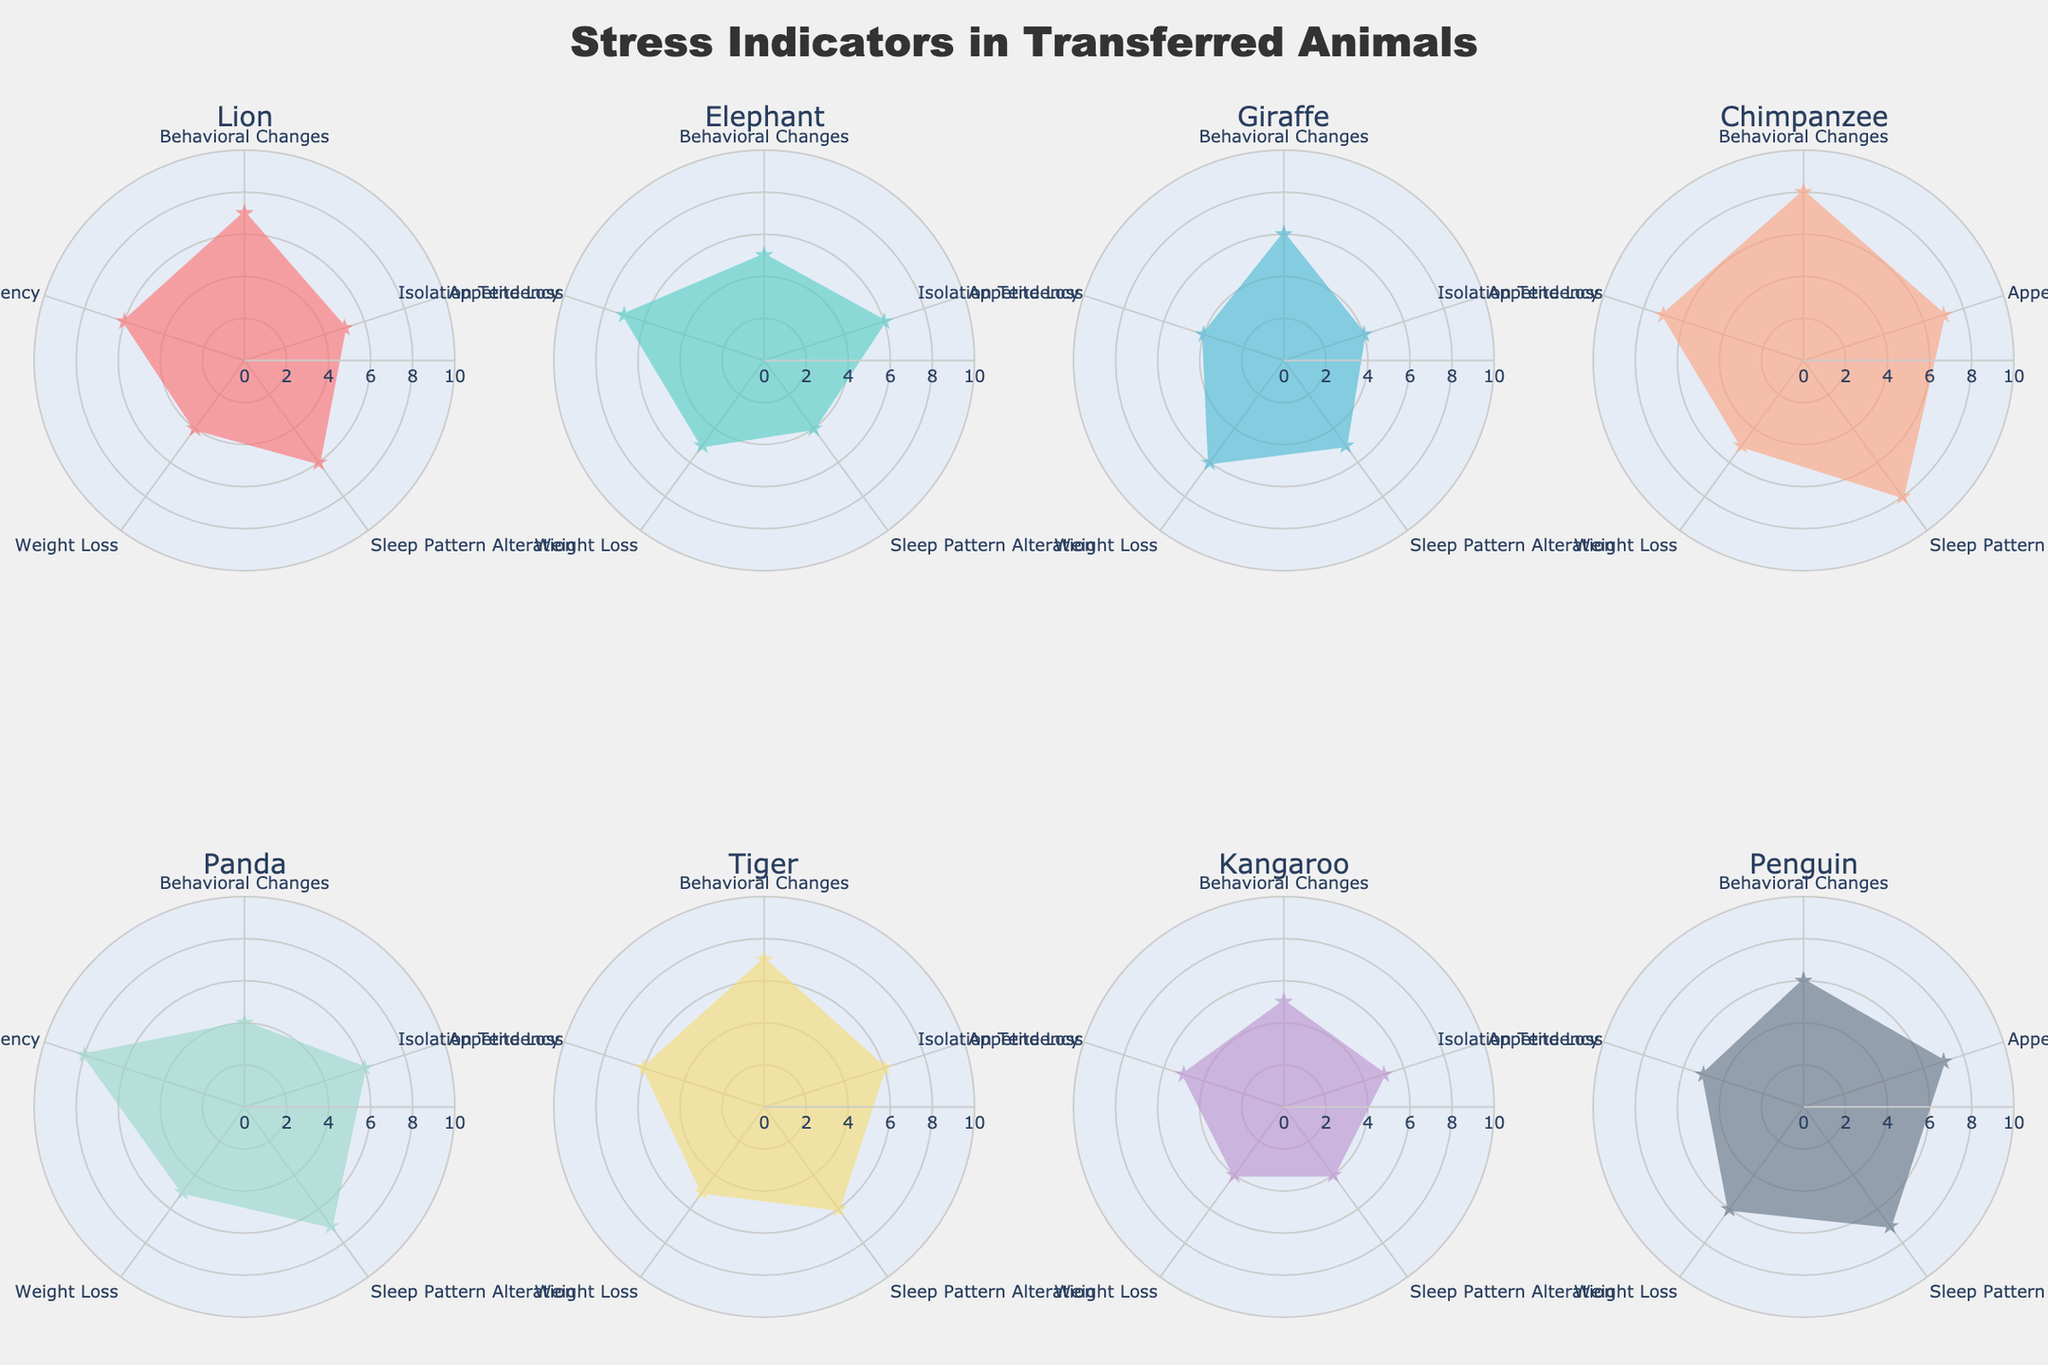What's the title of the figure? The title is usually displayed prominently at the top of the chart. It summarizes the main topic of the figure. In this case, the title says "Stress Indicators in Transferred Animals".
Answer: Stress Indicators in Transferred Animals What are the five stress indicators considered in the radar charts? Each radar chart has labeled axes representing different stress indicators. The five indicators considered are "Behavioral Changes," "Appetite Loss," "Sleep Pattern Alteration," "Weight Loss," and "Isolation Tendency."
Answer: Behavioral Changes, Appetite Loss, Sleep Pattern Alteration, Weight Loss, Isolation Tendency Which species has the highest value for Sleep Pattern Alteration? From the radar charts, you can look for the species with the highest value on the axis labeled "Sleep Pattern Alteration." The Chimpanzee shows the highest value with a score of 8.
Answer: Chimpanzee Which species shows the lowest Behavioral Changes? You need to identify the species with the smallest value on the "Behavioral Changes" axis on the radar charts. The Panda shows the lowest value with a score of 4.
Answer: Panda What is the average value of Isolation Tendency across all species? Sum the Isolation Tendency values for all species (6 + 7 + 4 + 7 + 8 + 6 + 5 + 5 = 48). Then divide by the number of species (8). The average value is 48/8 = 6.
Answer: 6 Which species has the most balanced profile across all stress indicators? A species with a balanced profile will have similar values across all indicators. By visual inspection, the Tiger and Penguin have more balanced profiles with similar scores ranging between 5 and 7.
Answer: Tiger, Penguin Which species compares closest to Giraffe in terms of Weight Loss? Examine the Weight Loss axis for species with a value close to the Giraffe's 6. Both the Lion and Penguin have values that are close to this.
Answer: Lion, Penguin What range of values do the radial axes cover in the radar charts? Observing the radar chart, the radial axes range from 0 to 10, as indicated by the scale marking each axis starting from the center (0) to the outermost point (10).
Answer: 0 to 10 